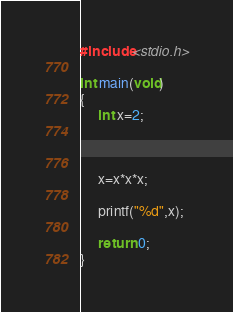<code> <loc_0><loc_0><loc_500><loc_500><_C_>#include<stdio.h>

int main(void)
{
     int x=2;     

      

     x=x*x*x;

     printf("%d",x);

     return 0;
}</code> 